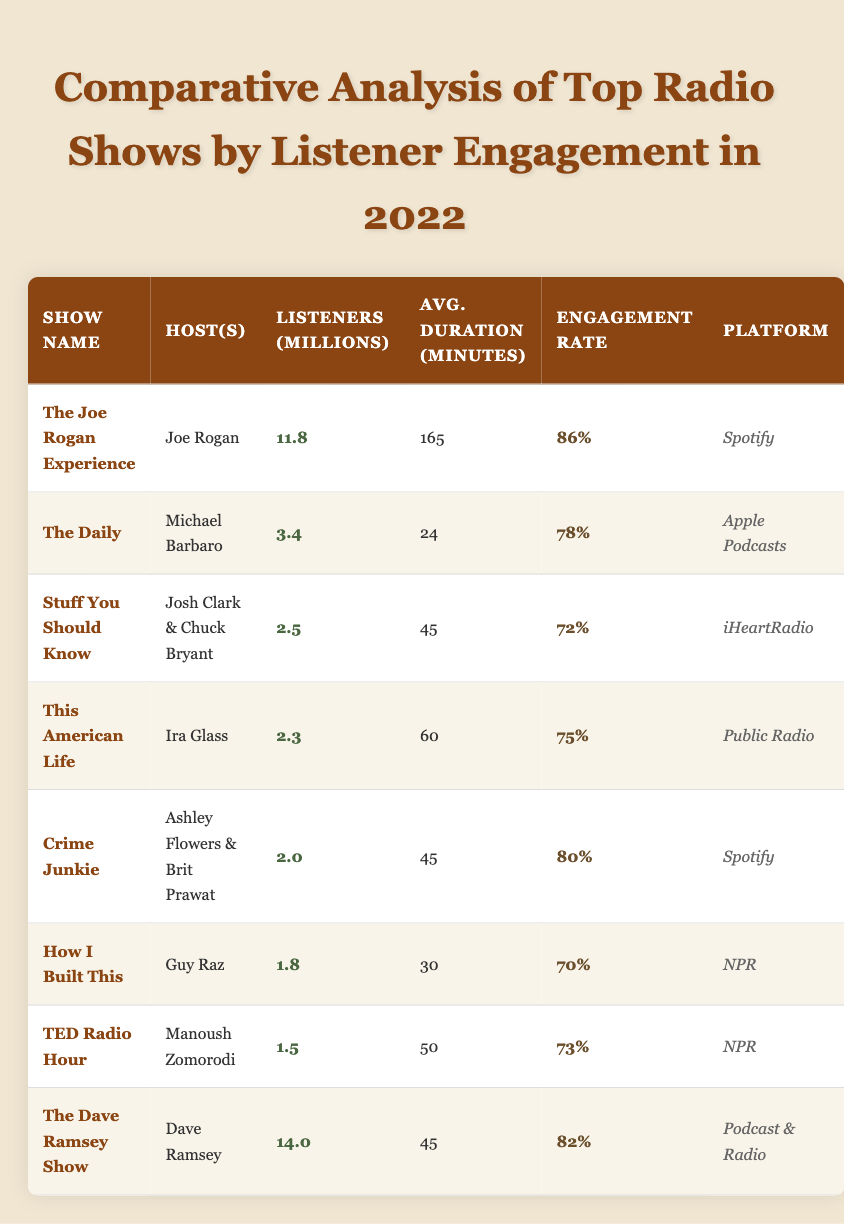What is the engagement rate of "The Joe Rogan Experience"? The engagement rate for "The Joe Rogan Experience" can be found in the corresponding row of the table, which shows an engagement rate of 86%.
Answer: 86% How many listeners does "The Daily" have in millions? Referring to the entry for "The Daily," the table states that it has 3.4 million listeners.
Answer: 3.4 million Which show has the longest average duration? The show with the longest average duration is "The Joe Rogan Experience," with an average duration of 165 minutes, as indicated in the table.
Answer: "The Joe Rogan Experience" What is the average engagement rate of the shows listed? To find the average engagement rate, sum the engagement rates (86%, 78%, 72%, 75%, 80%, 70%, 73%, 82%), then divide by 8 (the number of shows). The sum is 615%, so the average is 615/8 = 76.875%.
Answer: 76.88% Which show had the highest number of listeners? By reviewing the listener counts, "The Dave Ramsey Show" has the highest number of listeners with 14.0 million, as shown in the listeners column.
Answer: "The Dave Ramsey Show" Are all shows available on multiple platforms? No, not all shows are available on multiple platforms; for instance, "Crime Junkie" and "The Joe Rogan Experience" are each listed only on one platform in the table.
Answer: No What is the difference in engagement rates between "Stuff You Should Know" and "TED Radio Hour"? The engagement rate for "Stuff You Should Know" is 72%, and for "TED Radio Hour" it is 73%. The difference is 73% - 72% = 1%.
Answer: 1% List the shows that have an engagement rate above 80%. The shows with an engagement rate above 80% are "The Joe Rogan Experience" (86%) and "The Dave Ramsey Show" (82%). Both entries can be found in the engagement rate column.
Answer: "The Joe Rogan Experience" and "The Dave Ramsey Show" Which platform has the highest average listener count for its shows? "Spotify" has two shows: "The Joe Rogan Experience" (11.8 million) and "Crime Junkie" (2.0 million). The total listener count for Spotify is 11.8 + 2.0 = 13.8 million. Other platforms can be summed similarly, but none exceeds this total.
Answer: Spotify What percentage of shows have an engagement rate of 75% or higher? Analyzing the engagement rates, four shows have rates of 75% or higher (The Joe Rogan Experience, The Daily, Crime Junkie, and The Dave Ramsey Show). Since there are 8 total shows, the percentage is (4/8) * 100 = 50%.
Answer: 50% 